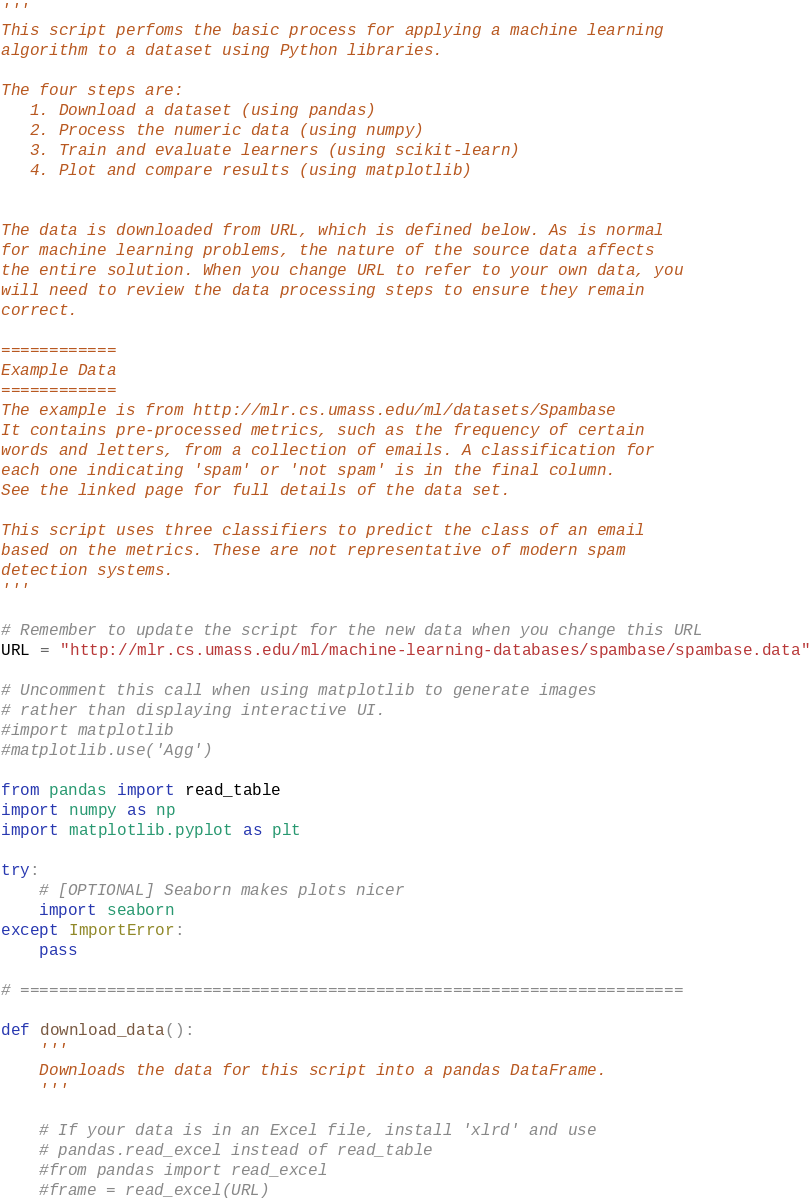<code> <loc_0><loc_0><loc_500><loc_500><_Python_>'''
This script perfoms the basic process for applying a machine learning
algorithm to a dataset using Python libraries.

The four steps are:
   1. Download a dataset (using pandas)
   2. Process the numeric data (using numpy)
   3. Train and evaluate learners (using scikit-learn)
   4. Plot and compare results (using matplotlib)


The data is downloaded from URL, which is defined below. As is normal
for machine learning problems, the nature of the source data affects
the entire solution. When you change URL to refer to your own data, you
will need to review the data processing steps to ensure they remain
correct.

============
Example Data
============
The example is from http://mlr.cs.umass.edu/ml/datasets/Spambase
It contains pre-processed metrics, such as the frequency of certain
words and letters, from a collection of emails. A classification for
each one indicating 'spam' or 'not spam' is in the final column.
See the linked page for full details of the data set.

This script uses three classifiers to predict the class of an email
based on the metrics. These are not representative of modern spam
detection systems.
'''

# Remember to update the script for the new data when you change this URL
URL = "http://mlr.cs.umass.edu/ml/machine-learning-databases/spambase/spambase.data"

# Uncomment this call when using matplotlib to generate images
# rather than displaying interactive UI.
#import matplotlib
#matplotlib.use('Agg')

from pandas import read_table
import numpy as np
import matplotlib.pyplot as plt

try:
    # [OPTIONAL] Seaborn makes plots nicer
    import seaborn
except ImportError:
    pass

# =====================================================================

def download_data():
    '''
    Downloads the data for this script into a pandas DataFrame.
    '''

    # If your data is in an Excel file, install 'xlrd' and use
    # pandas.read_excel instead of read_table
    #from pandas import read_excel
    #frame = read_excel(URL)
</code> 